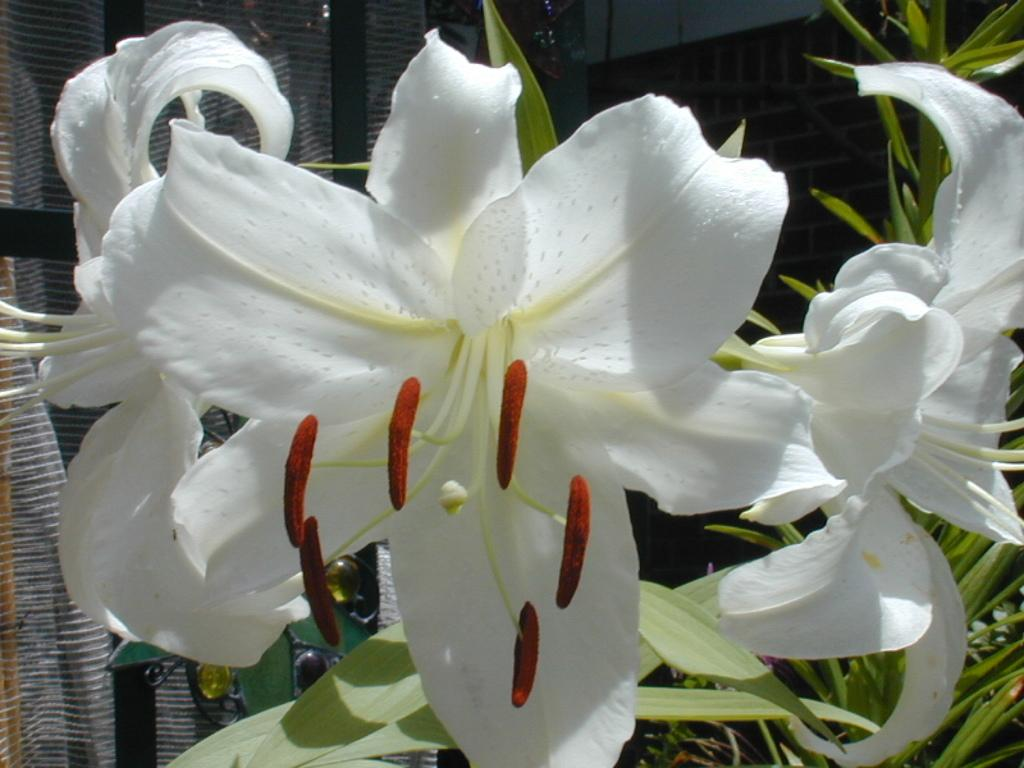What type of flora can be seen in the image? There are flowers in the image. What color are the flowers? The flowers are white in color. Are there any other plants visible in the image? Yes, there are plants in the image. What can be seen in the background of the image? There is a wall and a glass door in the background of the image. What type of rhythm is being played by the flowers in the image? There is no rhythm being played by the flowers in the image, as flowers do not produce sound or music. 